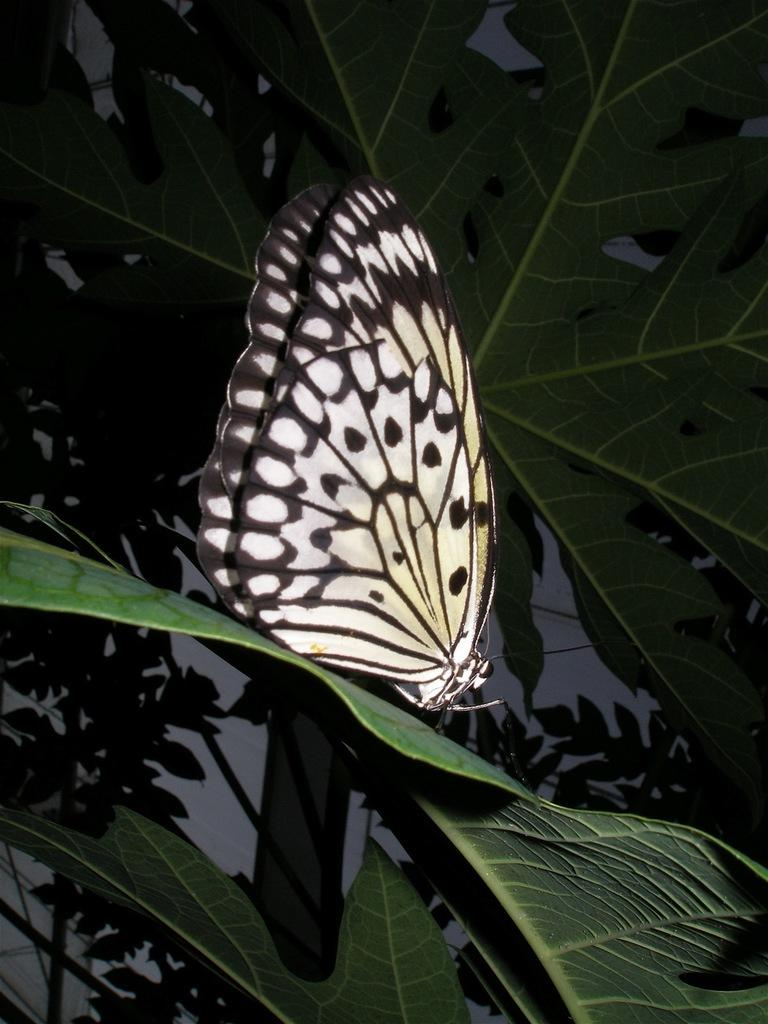What is the main subject of the image? There is a butterfly on a leaf in the image. What else can be seen in the image besides the butterfly? There are plants in the image. What is the background of the image? The background of the image appears to be a wall. Can you see the crown on the butterfly's head in the image? There is no crown present on the butterfly's head in the image. 